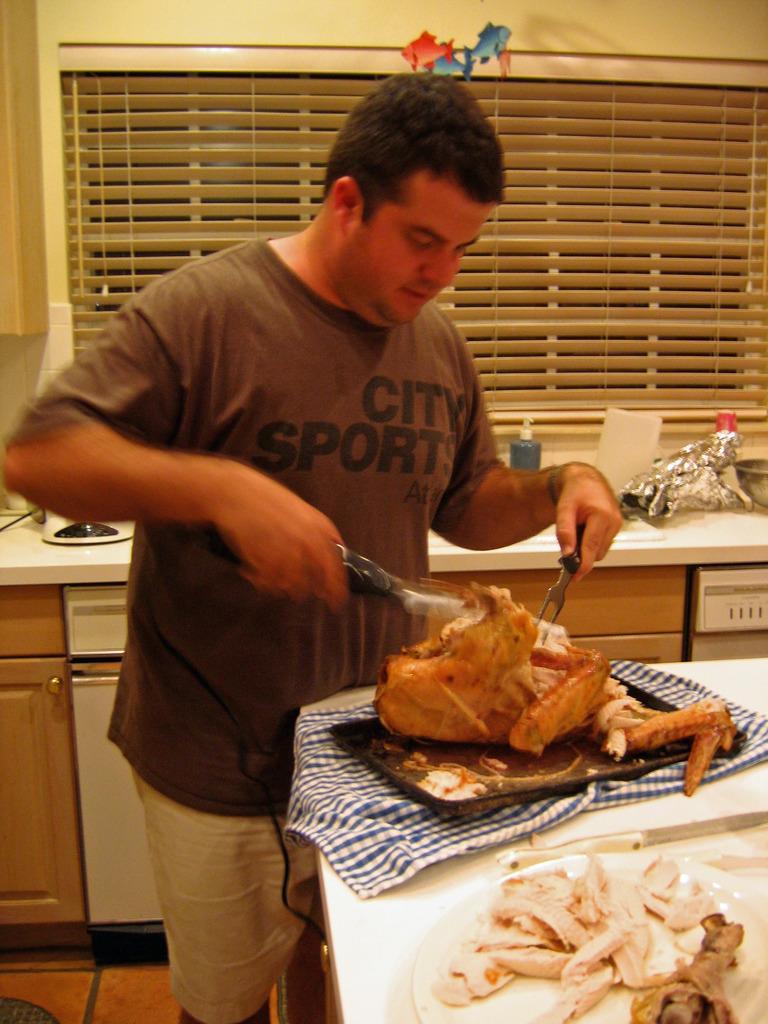Can you describe this image briefly? In the background we can see a bottle and other objects on a platform. Here we can see a man wearing a t-shirt and standing near to a platform. He is holding objects in his hands. On a platform we can see meat in a tray. We can see food in a white plate. Here we can see a white and blue cloth. We can see cupboards and this is a floor. 